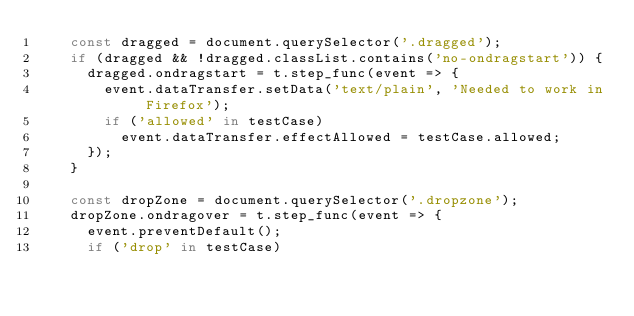Convert code to text. <code><loc_0><loc_0><loc_500><loc_500><_JavaScript_>    const dragged = document.querySelector('.dragged');
    if (dragged && !dragged.classList.contains('no-ondragstart')) {
      dragged.ondragstart = t.step_func(event => {
        event.dataTransfer.setData('text/plain', 'Needed to work in Firefox');
        if ('allowed' in testCase)
          event.dataTransfer.effectAllowed = testCase.allowed;
      });
    }

    const dropZone = document.querySelector('.dropzone');
    dropZone.ondragover = t.step_func(event => {
      event.preventDefault();
      if ('drop' in testCase)</code> 